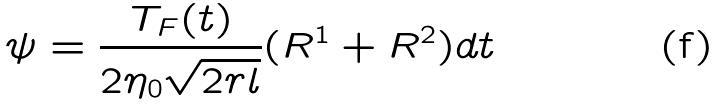Convert formula to latex. <formula><loc_0><loc_0><loc_500><loc_500>\psi = \frac { T _ { F } ( t ) } { 2 \eta _ { 0 } \sqrt { 2 r l } } ( R ^ { 1 } + R ^ { 2 } ) d t</formula> 